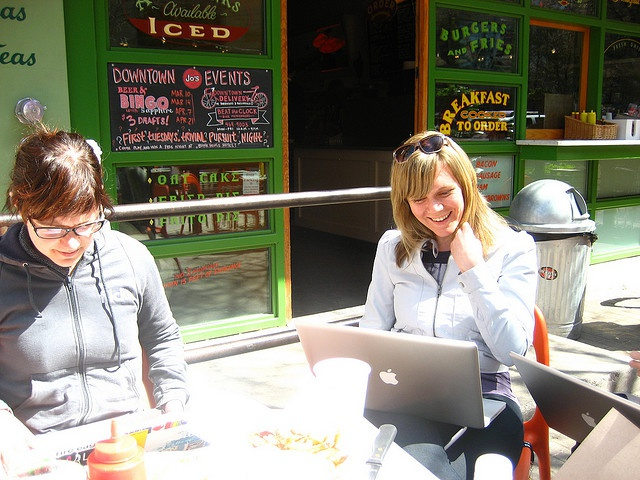Describe the objects in this image and their specific colors. I can see people in darkgreen, white, gray, darkgray, and maroon tones, people in darkgreen, white, black, and tan tones, dining table in darkgreen, white, khaki, salmon, and darkgray tones, laptop in darkgreen, gray, darkgray, white, and tan tones, and laptop in darkgreen, black, and gray tones in this image. 